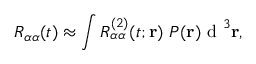<formula> <loc_0><loc_0><loc_500><loc_500>R _ { \alpha \alpha } ( t ) \approx \int R _ { \alpha \alpha } ^ { ( 2 ) } ( t ; { r } ) \ P ( { r } ) { d } ^ { 3 } { r } ,</formula> 